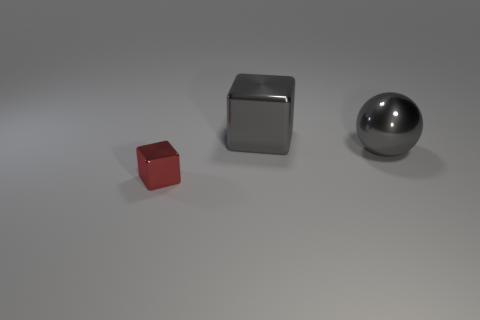Can you estimate the size of these objects? While I don't have specific measurements, based on the perspective and relationships between the objects, the small red cube appears to be quite tiny, perhaps a couple of centimeters across. The middle metal block might be roughly equivalent to the size of a small jewelry box. The metallic ball on the right could be similar in size to a standard billiard ball. And what about their relative distances? Can you infer which is closer or farther away from the viewer? Certainly. In the image, the objects are positioned in a way that the small red object is the closest to the viewer, the metal block is in the middle ground, and the metallic sphere is the farthest away. This is evident through their relative sizes, as objects appear smaller the further they are due to the principles of perspective. 